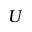<formula> <loc_0><loc_0><loc_500><loc_500>U</formula> 